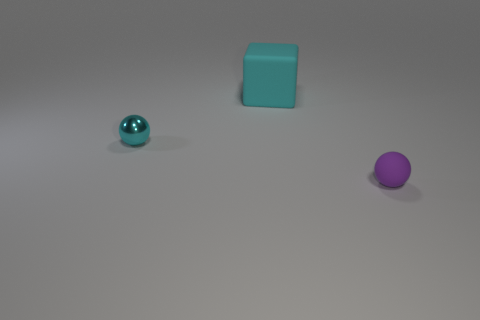Add 3 shiny balls. How many objects exist? 6 Subtract 0 brown cylinders. How many objects are left? 3 Subtract all blocks. How many objects are left? 2 Subtract 2 balls. How many balls are left? 0 Subtract all gray blocks. Subtract all yellow cylinders. How many blocks are left? 1 Subtract all purple spheres. How many yellow cubes are left? 0 Subtract all large blue balls. Subtract all big cyan rubber things. How many objects are left? 2 Add 1 big cyan cubes. How many big cyan cubes are left? 2 Add 3 cyan metal things. How many cyan metal things exist? 4 Subtract all cyan spheres. How many spheres are left? 1 